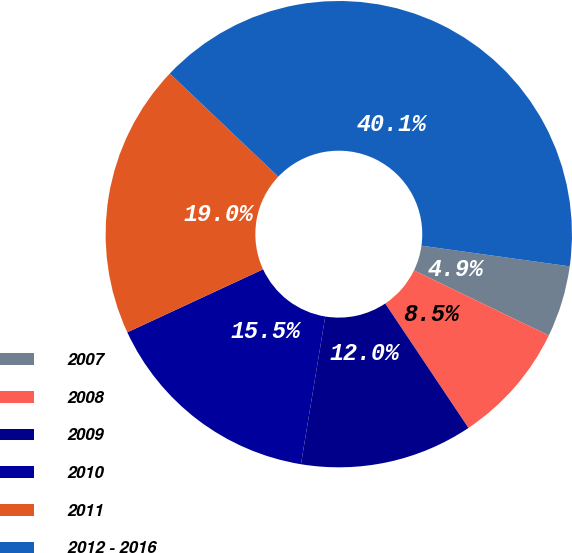Convert chart. <chart><loc_0><loc_0><loc_500><loc_500><pie_chart><fcel>2007<fcel>2008<fcel>2009<fcel>2010<fcel>2011<fcel>2012 - 2016<nl><fcel>4.95%<fcel>8.46%<fcel>11.98%<fcel>15.49%<fcel>19.01%<fcel>40.11%<nl></chart> 